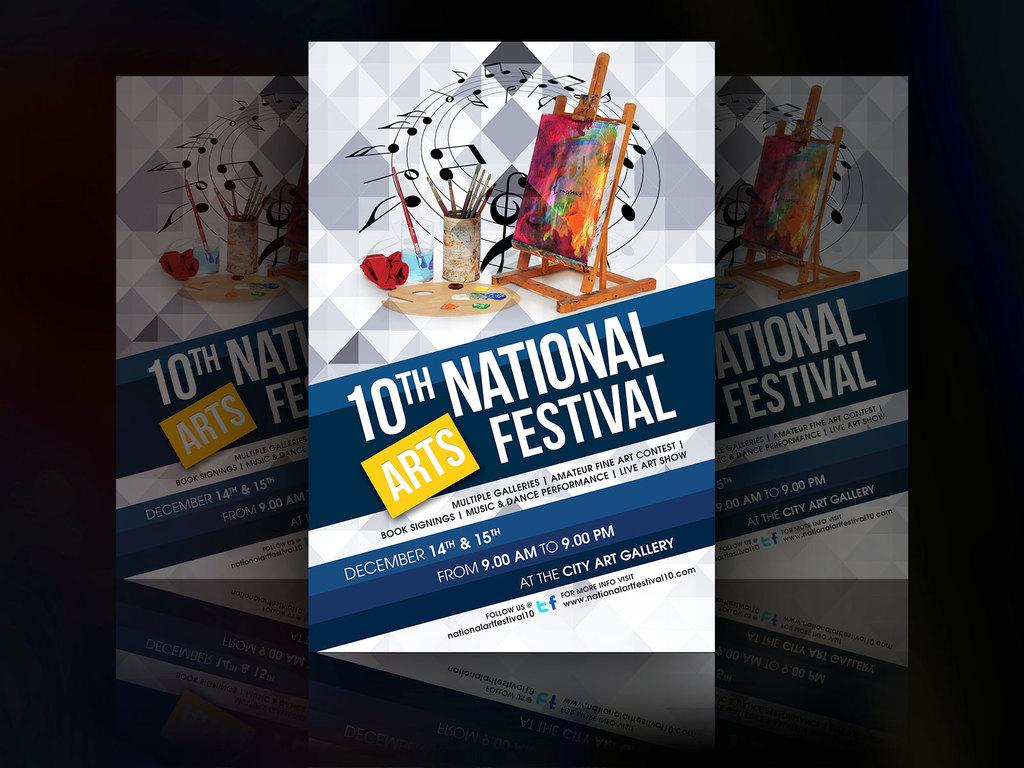<image>
Render a clear and concise summary of the photo. A program for the 10th National Arts Festival depicts an easel, paints and a painting in progress. 